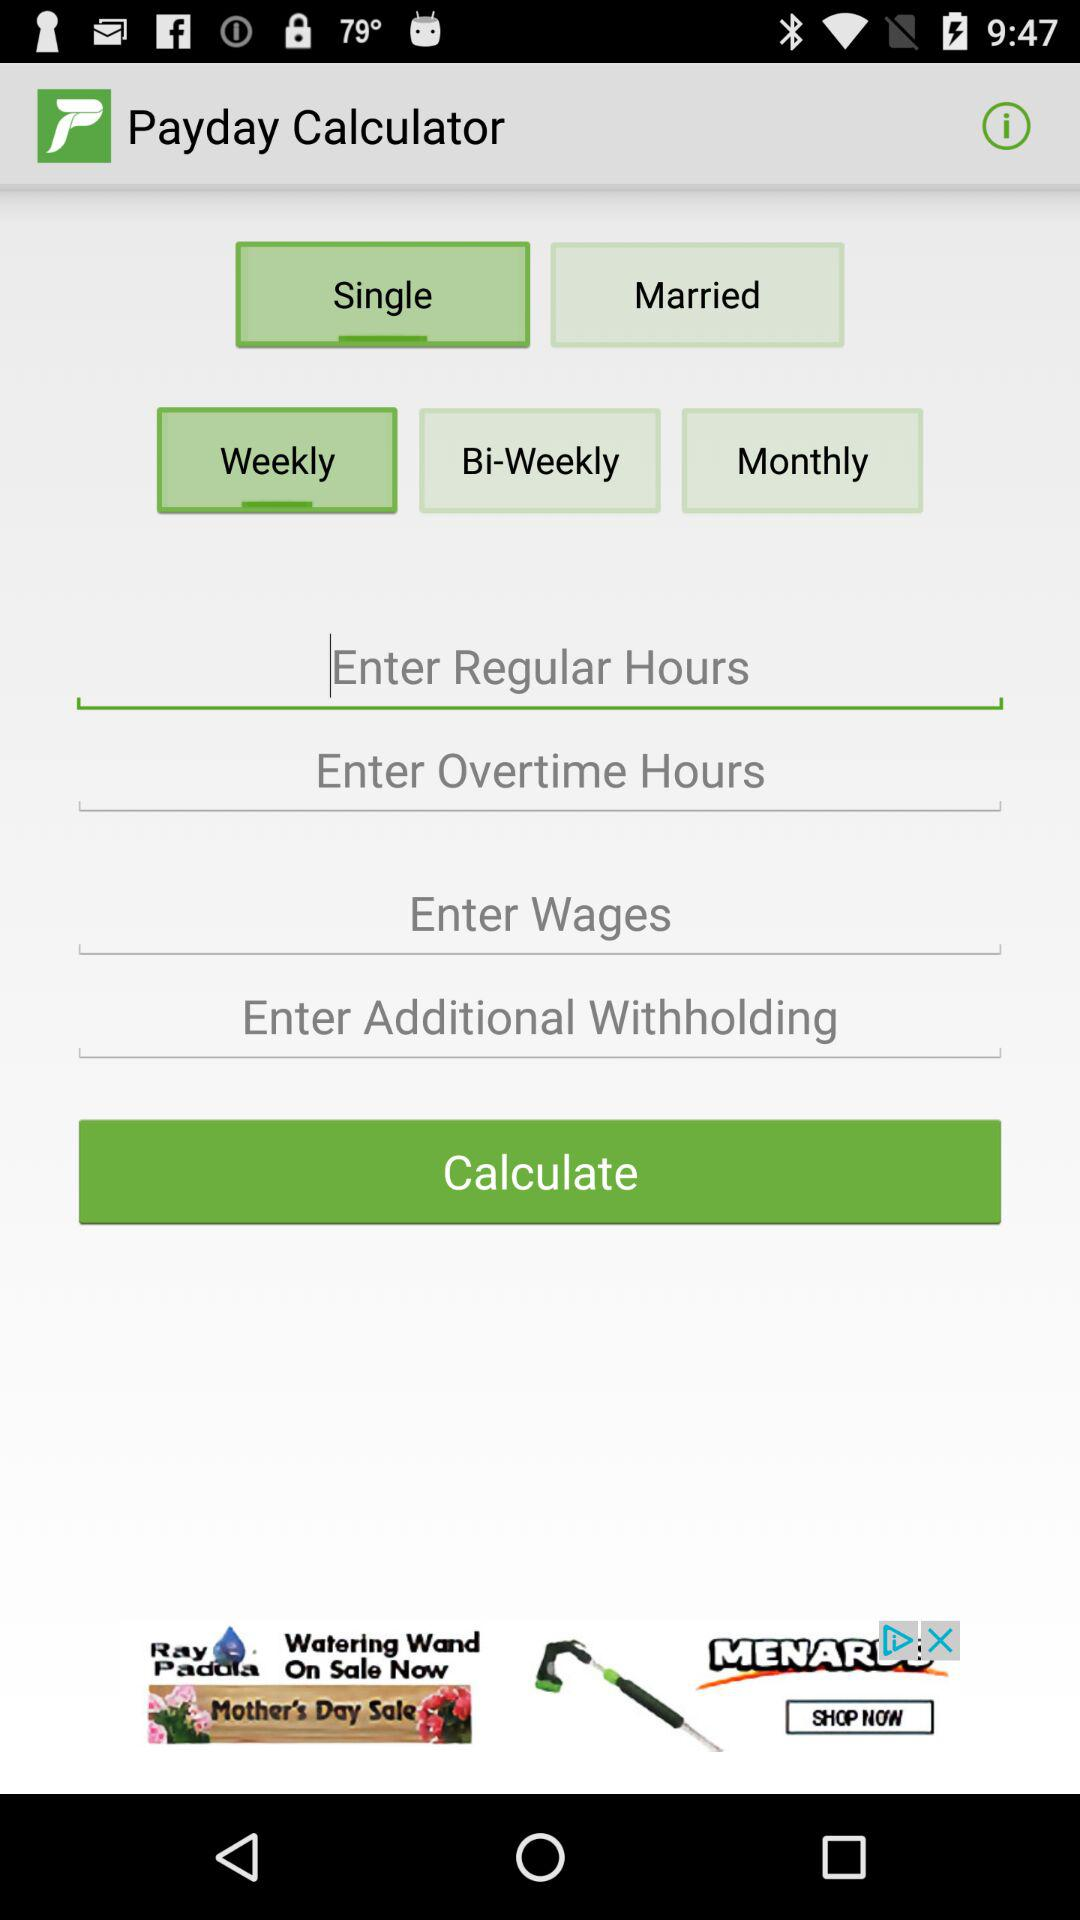What is the selected marital status? The selected marital status is "Single". 